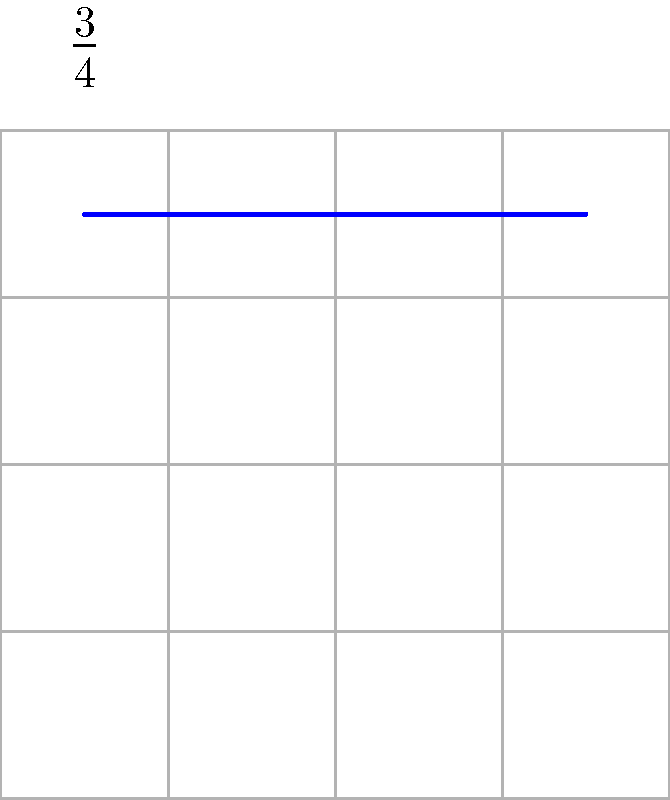Given the rhythmic pattern represented in the time signature grid above, which follows a 3/4 time signature, what is the order of the cyclic group formed by the beat pattern if we consider each measure as an element of the group? To determine the order of the cyclic group formed by the beat pattern, we need to follow these steps:

1. Identify the time signature: The time signature is 3/4, meaning there are 3 beats per measure, with the quarter note getting one beat.

2. Analyze the beat pattern: The grid shows 4 equally spaced notes, which implies that each note is a quarter note.

3. Determine the length of the pattern: Since there are 4 quarter notes in a 3/4 time signature, the pattern extends beyond a single measure. It takes 4/3 of a measure to complete one full cycle of the pattern.

4. Calculate the number of measures needed for a complete cycle: To find when the pattern aligns with the measure boundaries, we need to find the least common multiple (LCM) of 3 (beats per measure) and 4 (notes in the pattern).

   LCM(3,4) = 12

5. Interpret the result: It takes 12 beats for the pattern to align with the measure boundaries. This is equivalent to 4 complete measures (12 beats ÷ 3 beats per measure = 4 measures).

6. Conclude: The order of the cyclic group is 4, as it takes 4 iterations of the basic measure for the pattern to return to its starting point.
Answer: 4 